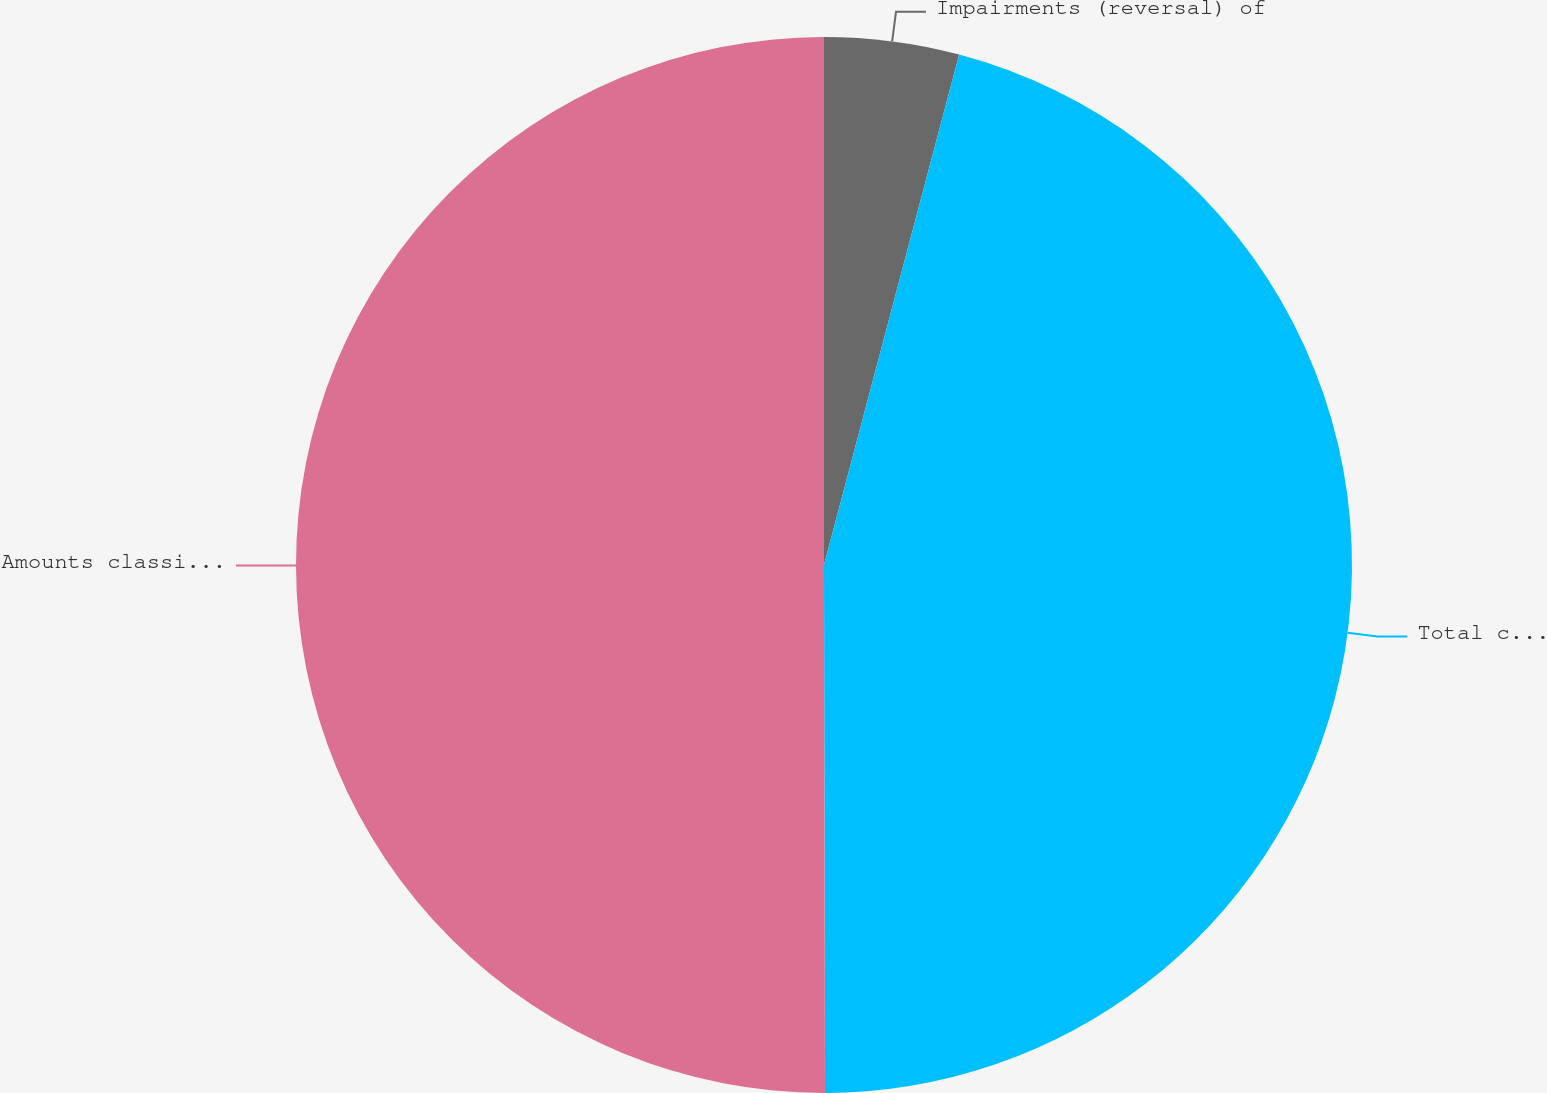Convert chart to OTSL. <chart><loc_0><loc_0><loc_500><loc_500><pie_chart><fcel>Impairments (reversal) of<fcel>Total consolidated impairments<fcel>Amounts classified as<nl><fcel>4.12%<fcel>45.85%<fcel>50.03%<nl></chart> 